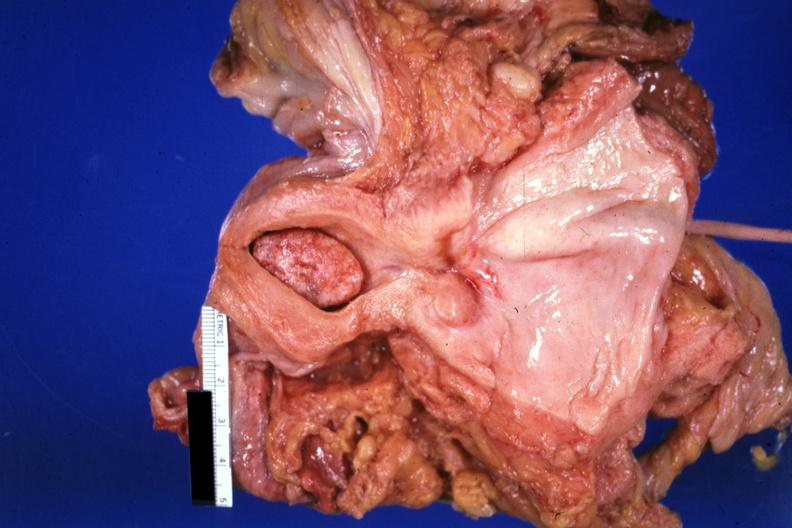does this image show large senile type endometrial polyp?
Answer the question using a single word or phrase. Yes 